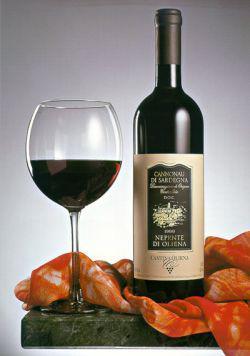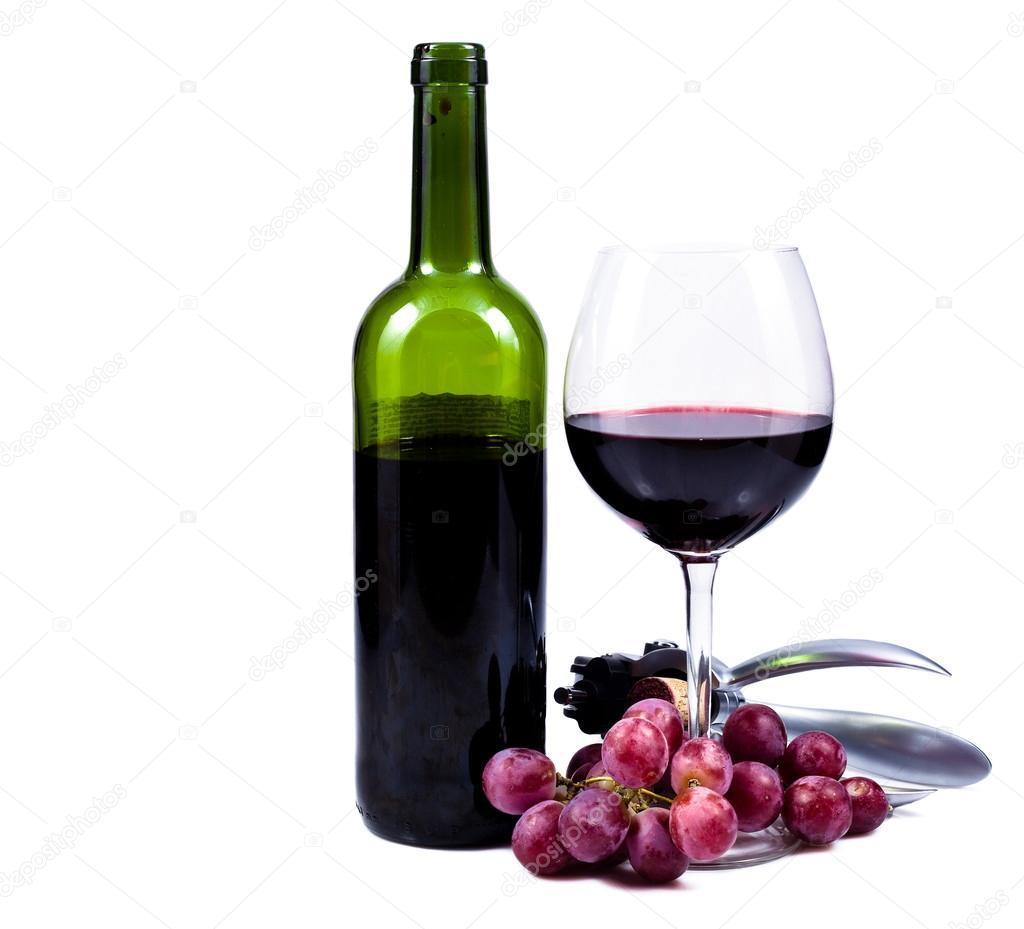The first image is the image on the left, the second image is the image on the right. For the images shown, is this caption "There is exactly one wineglass sitting on the left side of the bottle in the image on the left." true? Answer yes or no. Yes. The first image is the image on the left, the second image is the image on the right. Evaluate the accuracy of this statement regarding the images: "One of the bottles of wine is green and sits near a pile of grapes.". Is it true? Answer yes or no. Yes. 